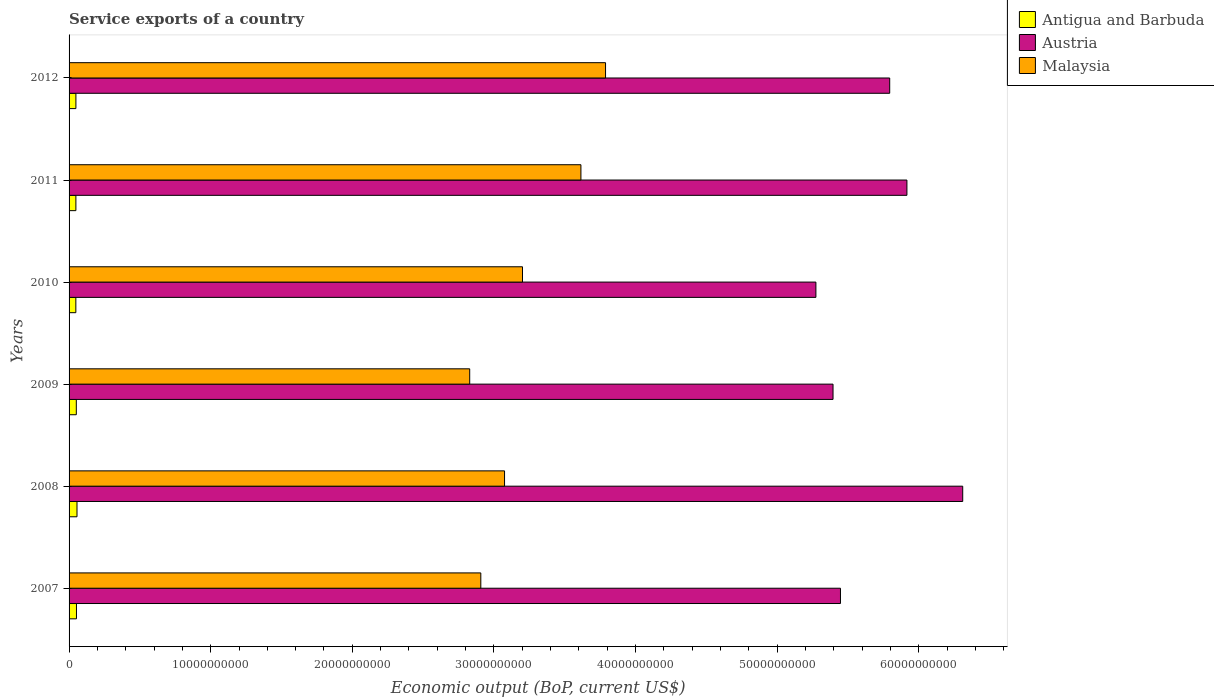How many different coloured bars are there?
Offer a very short reply. 3. How many groups of bars are there?
Provide a short and direct response. 6. Are the number of bars per tick equal to the number of legend labels?
Provide a succinct answer. Yes. How many bars are there on the 3rd tick from the top?
Your answer should be very brief. 3. How many bars are there on the 1st tick from the bottom?
Your answer should be compact. 3. In how many cases, is the number of bars for a given year not equal to the number of legend labels?
Ensure brevity in your answer.  0. What is the service exports in Antigua and Barbuda in 2012?
Keep it short and to the point. 4.83e+08. Across all years, what is the maximum service exports in Antigua and Barbuda?
Give a very brief answer. 5.60e+08. Across all years, what is the minimum service exports in Malaysia?
Your answer should be compact. 2.83e+1. In which year was the service exports in Malaysia minimum?
Give a very brief answer. 2009. What is the total service exports in Antigua and Barbuda in the graph?
Your response must be concise. 3.04e+09. What is the difference between the service exports in Antigua and Barbuda in 2009 and that in 2011?
Your answer should be compact. 2.93e+07. What is the difference between the service exports in Malaysia in 2010 and the service exports in Antigua and Barbuda in 2011?
Offer a very short reply. 3.15e+1. What is the average service exports in Austria per year?
Keep it short and to the point. 5.69e+1. In the year 2010, what is the difference between the service exports in Antigua and Barbuda and service exports in Malaysia?
Offer a very short reply. -3.15e+1. In how many years, is the service exports in Austria greater than 8000000000 US$?
Offer a terse response. 6. What is the ratio of the service exports in Antigua and Barbuda in 2007 to that in 2008?
Provide a short and direct response. 0.93. Is the service exports in Austria in 2010 less than that in 2011?
Keep it short and to the point. Yes. Is the difference between the service exports in Antigua and Barbuda in 2009 and 2012 greater than the difference between the service exports in Malaysia in 2009 and 2012?
Give a very brief answer. Yes. What is the difference between the highest and the second highest service exports in Austria?
Provide a succinct answer. 3.94e+09. What is the difference between the highest and the lowest service exports in Austria?
Ensure brevity in your answer.  1.04e+1. In how many years, is the service exports in Antigua and Barbuda greater than the average service exports in Antigua and Barbuda taken over all years?
Your answer should be compact. 3. Is the sum of the service exports in Malaysia in 2007 and 2009 greater than the maximum service exports in Austria across all years?
Offer a terse response. No. What does the 1st bar from the top in 2007 represents?
Your answer should be very brief. Malaysia. What does the 3rd bar from the bottom in 2009 represents?
Provide a succinct answer. Malaysia. What is the difference between two consecutive major ticks on the X-axis?
Your response must be concise. 1.00e+1. Are the values on the major ticks of X-axis written in scientific E-notation?
Your answer should be very brief. No. Does the graph contain any zero values?
Provide a succinct answer. No. How many legend labels are there?
Provide a short and direct response. 3. What is the title of the graph?
Your answer should be very brief. Service exports of a country. What is the label or title of the X-axis?
Make the answer very short. Economic output (BoP, current US$). What is the Economic output (BoP, current US$) in Antigua and Barbuda in 2007?
Give a very brief answer. 5.22e+08. What is the Economic output (BoP, current US$) in Austria in 2007?
Your response must be concise. 5.45e+1. What is the Economic output (BoP, current US$) of Malaysia in 2007?
Your response must be concise. 2.91e+1. What is the Economic output (BoP, current US$) of Antigua and Barbuda in 2008?
Make the answer very short. 5.60e+08. What is the Economic output (BoP, current US$) in Austria in 2008?
Your answer should be compact. 6.31e+1. What is the Economic output (BoP, current US$) in Malaysia in 2008?
Give a very brief answer. 3.08e+1. What is the Economic output (BoP, current US$) in Antigua and Barbuda in 2009?
Ensure brevity in your answer.  5.11e+08. What is the Economic output (BoP, current US$) of Austria in 2009?
Offer a terse response. 5.39e+1. What is the Economic output (BoP, current US$) in Malaysia in 2009?
Offer a very short reply. 2.83e+1. What is the Economic output (BoP, current US$) of Antigua and Barbuda in 2010?
Your response must be concise. 4.78e+08. What is the Economic output (BoP, current US$) in Austria in 2010?
Offer a very short reply. 5.27e+1. What is the Economic output (BoP, current US$) of Malaysia in 2010?
Ensure brevity in your answer.  3.20e+1. What is the Economic output (BoP, current US$) in Antigua and Barbuda in 2011?
Provide a succinct answer. 4.82e+08. What is the Economic output (BoP, current US$) in Austria in 2011?
Your answer should be very brief. 5.92e+1. What is the Economic output (BoP, current US$) of Malaysia in 2011?
Give a very brief answer. 3.61e+1. What is the Economic output (BoP, current US$) of Antigua and Barbuda in 2012?
Provide a short and direct response. 4.83e+08. What is the Economic output (BoP, current US$) of Austria in 2012?
Give a very brief answer. 5.79e+1. What is the Economic output (BoP, current US$) of Malaysia in 2012?
Make the answer very short. 3.79e+1. Across all years, what is the maximum Economic output (BoP, current US$) in Antigua and Barbuda?
Your answer should be very brief. 5.60e+08. Across all years, what is the maximum Economic output (BoP, current US$) in Austria?
Your answer should be very brief. 6.31e+1. Across all years, what is the maximum Economic output (BoP, current US$) of Malaysia?
Provide a short and direct response. 3.79e+1. Across all years, what is the minimum Economic output (BoP, current US$) in Antigua and Barbuda?
Your response must be concise. 4.78e+08. Across all years, what is the minimum Economic output (BoP, current US$) of Austria?
Your answer should be very brief. 5.27e+1. Across all years, what is the minimum Economic output (BoP, current US$) of Malaysia?
Keep it short and to the point. 2.83e+1. What is the total Economic output (BoP, current US$) of Antigua and Barbuda in the graph?
Your answer should be compact. 3.04e+09. What is the total Economic output (BoP, current US$) of Austria in the graph?
Keep it short and to the point. 3.41e+11. What is the total Economic output (BoP, current US$) of Malaysia in the graph?
Your answer should be very brief. 1.94e+11. What is the difference between the Economic output (BoP, current US$) of Antigua and Barbuda in 2007 and that in 2008?
Ensure brevity in your answer.  -3.80e+07. What is the difference between the Economic output (BoP, current US$) of Austria in 2007 and that in 2008?
Make the answer very short. -8.63e+09. What is the difference between the Economic output (BoP, current US$) of Malaysia in 2007 and that in 2008?
Your answer should be very brief. -1.68e+09. What is the difference between the Economic output (BoP, current US$) of Antigua and Barbuda in 2007 and that in 2009?
Make the answer very short. 1.11e+07. What is the difference between the Economic output (BoP, current US$) of Austria in 2007 and that in 2009?
Provide a short and direct response. 5.24e+08. What is the difference between the Economic output (BoP, current US$) in Malaysia in 2007 and that in 2009?
Provide a succinct answer. 7.84e+08. What is the difference between the Economic output (BoP, current US$) in Antigua and Barbuda in 2007 and that in 2010?
Provide a succinct answer. 4.39e+07. What is the difference between the Economic output (BoP, current US$) of Austria in 2007 and that in 2010?
Provide a succinct answer. 1.73e+09. What is the difference between the Economic output (BoP, current US$) of Malaysia in 2007 and that in 2010?
Provide a short and direct response. -2.94e+09. What is the difference between the Economic output (BoP, current US$) of Antigua and Barbuda in 2007 and that in 2011?
Your answer should be very brief. 4.04e+07. What is the difference between the Economic output (BoP, current US$) of Austria in 2007 and that in 2011?
Ensure brevity in your answer.  -4.69e+09. What is the difference between the Economic output (BoP, current US$) in Malaysia in 2007 and that in 2011?
Offer a terse response. -7.07e+09. What is the difference between the Economic output (BoP, current US$) of Antigua and Barbuda in 2007 and that in 2012?
Give a very brief answer. 3.95e+07. What is the difference between the Economic output (BoP, current US$) in Austria in 2007 and that in 2012?
Ensure brevity in your answer.  -3.48e+09. What is the difference between the Economic output (BoP, current US$) in Malaysia in 2007 and that in 2012?
Make the answer very short. -8.81e+09. What is the difference between the Economic output (BoP, current US$) in Antigua and Barbuda in 2008 and that in 2009?
Offer a terse response. 4.91e+07. What is the difference between the Economic output (BoP, current US$) of Austria in 2008 and that in 2009?
Offer a terse response. 9.16e+09. What is the difference between the Economic output (BoP, current US$) in Malaysia in 2008 and that in 2009?
Offer a very short reply. 2.46e+09. What is the difference between the Economic output (BoP, current US$) in Antigua and Barbuda in 2008 and that in 2010?
Your answer should be very brief. 8.19e+07. What is the difference between the Economic output (BoP, current US$) in Austria in 2008 and that in 2010?
Provide a short and direct response. 1.04e+1. What is the difference between the Economic output (BoP, current US$) in Malaysia in 2008 and that in 2010?
Your answer should be very brief. -1.27e+09. What is the difference between the Economic output (BoP, current US$) of Antigua and Barbuda in 2008 and that in 2011?
Your response must be concise. 7.84e+07. What is the difference between the Economic output (BoP, current US$) in Austria in 2008 and that in 2011?
Your answer should be very brief. 3.94e+09. What is the difference between the Economic output (BoP, current US$) of Malaysia in 2008 and that in 2011?
Provide a short and direct response. -5.39e+09. What is the difference between the Economic output (BoP, current US$) in Antigua and Barbuda in 2008 and that in 2012?
Provide a succinct answer. 7.75e+07. What is the difference between the Economic output (BoP, current US$) in Austria in 2008 and that in 2012?
Your answer should be compact. 5.16e+09. What is the difference between the Economic output (BoP, current US$) in Malaysia in 2008 and that in 2012?
Your answer should be compact. -7.13e+09. What is the difference between the Economic output (BoP, current US$) of Antigua and Barbuda in 2009 and that in 2010?
Keep it short and to the point. 3.28e+07. What is the difference between the Economic output (BoP, current US$) in Austria in 2009 and that in 2010?
Make the answer very short. 1.21e+09. What is the difference between the Economic output (BoP, current US$) of Malaysia in 2009 and that in 2010?
Offer a very short reply. -3.73e+09. What is the difference between the Economic output (BoP, current US$) in Antigua and Barbuda in 2009 and that in 2011?
Keep it short and to the point. 2.93e+07. What is the difference between the Economic output (BoP, current US$) in Austria in 2009 and that in 2011?
Provide a succinct answer. -5.22e+09. What is the difference between the Economic output (BoP, current US$) in Malaysia in 2009 and that in 2011?
Give a very brief answer. -7.85e+09. What is the difference between the Economic output (BoP, current US$) in Antigua and Barbuda in 2009 and that in 2012?
Give a very brief answer. 2.84e+07. What is the difference between the Economic output (BoP, current US$) of Austria in 2009 and that in 2012?
Ensure brevity in your answer.  -4.00e+09. What is the difference between the Economic output (BoP, current US$) in Malaysia in 2009 and that in 2012?
Provide a short and direct response. -9.59e+09. What is the difference between the Economic output (BoP, current US$) in Antigua and Barbuda in 2010 and that in 2011?
Make the answer very short. -3.49e+06. What is the difference between the Economic output (BoP, current US$) of Austria in 2010 and that in 2011?
Your response must be concise. -6.43e+09. What is the difference between the Economic output (BoP, current US$) of Malaysia in 2010 and that in 2011?
Your response must be concise. -4.13e+09. What is the difference between the Economic output (BoP, current US$) in Antigua and Barbuda in 2010 and that in 2012?
Your answer should be very brief. -4.39e+06. What is the difference between the Economic output (BoP, current US$) in Austria in 2010 and that in 2012?
Make the answer very short. -5.21e+09. What is the difference between the Economic output (BoP, current US$) of Malaysia in 2010 and that in 2012?
Offer a very short reply. -5.86e+09. What is the difference between the Economic output (BoP, current US$) in Antigua and Barbuda in 2011 and that in 2012?
Offer a terse response. -9.03e+05. What is the difference between the Economic output (BoP, current US$) of Austria in 2011 and that in 2012?
Your answer should be very brief. 1.22e+09. What is the difference between the Economic output (BoP, current US$) in Malaysia in 2011 and that in 2012?
Keep it short and to the point. -1.74e+09. What is the difference between the Economic output (BoP, current US$) in Antigua and Barbuda in 2007 and the Economic output (BoP, current US$) in Austria in 2008?
Your answer should be very brief. -6.26e+1. What is the difference between the Economic output (BoP, current US$) in Antigua and Barbuda in 2007 and the Economic output (BoP, current US$) in Malaysia in 2008?
Your answer should be very brief. -3.02e+1. What is the difference between the Economic output (BoP, current US$) in Austria in 2007 and the Economic output (BoP, current US$) in Malaysia in 2008?
Provide a short and direct response. 2.37e+1. What is the difference between the Economic output (BoP, current US$) in Antigua and Barbuda in 2007 and the Economic output (BoP, current US$) in Austria in 2009?
Your answer should be very brief. -5.34e+1. What is the difference between the Economic output (BoP, current US$) in Antigua and Barbuda in 2007 and the Economic output (BoP, current US$) in Malaysia in 2009?
Offer a very short reply. -2.78e+1. What is the difference between the Economic output (BoP, current US$) in Austria in 2007 and the Economic output (BoP, current US$) in Malaysia in 2009?
Offer a terse response. 2.62e+1. What is the difference between the Economic output (BoP, current US$) in Antigua and Barbuda in 2007 and the Economic output (BoP, current US$) in Austria in 2010?
Offer a very short reply. -5.22e+1. What is the difference between the Economic output (BoP, current US$) in Antigua and Barbuda in 2007 and the Economic output (BoP, current US$) in Malaysia in 2010?
Provide a short and direct response. -3.15e+1. What is the difference between the Economic output (BoP, current US$) in Austria in 2007 and the Economic output (BoP, current US$) in Malaysia in 2010?
Your answer should be very brief. 2.25e+1. What is the difference between the Economic output (BoP, current US$) in Antigua and Barbuda in 2007 and the Economic output (BoP, current US$) in Austria in 2011?
Provide a short and direct response. -5.86e+1. What is the difference between the Economic output (BoP, current US$) of Antigua and Barbuda in 2007 and the Economic output (BoP, current US$) of Malaysia in 2011?
Give a very brief answer. -3.56e+1. What is the difference between the Economic output (BoP, current US$) in Austria in 2007 and the Economic output (BoP, current US$) in Malaysia in 2011?
Provide a succinct answer. 1.83e+1. What is the difference between the Economic output (BoP, current US$) of Antigua and Barbuda in 2007 and the Economic output (BoP, current US$) of Austria in 2012?
Make the answer very short. -5.74e+1. What is the difference between the Economic output (BoP, current US$) of Antigua and Barbuda in 2007 and the Economic output (BoP, current US$) of Malaysia in 2012?
Your response must be concise. -3.74e+1. What is the difference between the Economic output (BoP, current US$) of Austria in 2007 and the Economic output (BoP, current US$) of Malaysia in 2012?
Your answer should be compact. 1.66e+1. What is the difference between the Economic output (BoP, current US$) in Antigua and Barbuda in 2008 and the Economic output (BoP, current US$) in Austria in 2009?
Your response must be concise. -5.34e+1. What is the difference between the Economic output (BoP, current US$) in Antigua and Barbuda in 2008 and the Economic output (BoP, current US$) in Malaysia in 2009?
Keep it short and to the point. -2.77e+1. What is the difference between the Economic output (BoP, current US$) in Austria in 2008 and the Economic output (BoP, current US$) in Malaysia in 2009?
Your response must be concise. 3.48e+1. What is the difference between the Economic output (BoP, current US$) of Antigua and Barbuda in 2008 and the Economic output (BoP, current US$) of Austria in 2010?
Provide a short and direct response. -5.22e+1. What is the difference between the Economic output (BoP, current US$) in Antigua and Barbuda in 2008 and the Economic output (BoP, current US$) in Malaysia in 2010?
Keep it short and to the point. -3.15e+1. What is the difference between the Economic output (BoP, current US$) of Austria in 2008 and the Economic output (BoP, current US$) of Malaysia in 2010?
Your response must be concise. 3.11e+1. What is the difference between the Economic output (BoP, current US$) of Antigua and Barbuda in 2008 and the Economic output (BoP, current US$) of Austria in 2011?
Give a very brief answer. -5.86e+1. What is the difference between the Economic output (BoP, current US$) in Antigua and Barbuda in 2008 and the Economic output (BoP, current US$) in Malaysia in 2011?
Ensure brevity in your answer.  -3.56e+1. What is the difference between the Economic output (BoP, current US$) of Austria in 2008 and the Economic output (BoP, current US$) of Malaysia in 2011?
Your response must be concise. 2.70e+1. What is the difference between the Economic output (BoP, current US$) of Antigua and Barbuda in 2008 and the Economic output (BoP, current US$) of Austria in 2012?
Make the answer very short. -5.74e+1. What is the difference between the Economic output (BoP, current US$) in Antigua and Barbuda in 2008 and the Economic output (BoP, current US$) in Malaysia in 2012?
Give a very brief answer. -3.73e+1. What is the difference between the Economic output (BoP, current US$) in Austria in 2008 and the Economic output (BoP, current US$) in Malaysia in 2012?
Keep it short and to the point. 2.52e+1. What is the difference between the Economic output (BoP, current US$) in Antigua and Barbuda in 2009 and the Economic output (BoP, current US$) in Austria in 2010?
Your answer should be very brief. -5.22e+1. What is the difference between the Economic output (BoP, current US$) in Antigua and Barbuda in 2009 and the Economic output (BoP, current US$) in Malaysia in 2010?
Keep it short and to the point. -3.15e+1. What is the difference between the Economic output (BoP, current US$) in Austria in 2009 and the Economic output (BoP, current US$) in Malaysia in 2010?
Make the answer very short. 2.19e+1. What is the difference between the Economic output (BoP, current US$) in Antigua and Barbuda in 2009 and the Economic output (BoP, current US$) in Austria in 2011?
Offer a terse response. -5.87e+1. What is the difference between the Economic output (BoP, current US$) of Antigua and Barbuda in 2009 and the Economic output (BoP, current US$) of Malaysia in 2011?
Offer a terse response. -3.56e+1. What is the difference between the Economic output (BoP, current US$) in Austria in 2009 and the Economic output (BoP, current US$) in Malaysia in 2011?
Your answer should be compact. 1.78e+1. What is the difference between the Economic output (BoP, current US$) of Antigua and Barbuda in 2009 and the Economic output (BoP, current US$) of Austria in 2012?
Give a very brief answer. -5.74e+1. What is the difference between the Economic output (BoP, current US$) of Antigua and Barbuda in 2009 and the Economic output (BoP, current US$) of Malaysia in 2012?
Give a very brief answer. -3.74e+1. What is the difference between the Economic output (BoP, current US$) of Austria in 2009 and the Economic output (BoP, current US$) of Malaysia in 2012?
Make the answer very short. 1.61e+1. What is the difference between the Economic output (BoP, current US$) in Antigua and Barbuda in 2010 and the Economic output (BoP, current US$) in Austria in 2011?
Offer a terse response. -5.87e+1. What is the difference between the Economic output (BoP, current US$) of Antigua and Barbuda in 2010 and the Economic output (BoP, current US$) of Malaysia in 2011?
Your response must be concise. -3.57e+1. What is the difference between the Economic output (BoP, current US$) in Austria in 2010 and the Economic output (BoP, current US$) in Malaysia in 2011?
Provide a succinct answer. 1.66e+1. What is the difference between the Economic output (BoP, current US$) of Antigua and Barbuda in 2010 and the Economic output (BoP, current US$) of Austria in 2012?
Your answer should be compact. -5.75e+1. What is the difference between the Economic output (BoP, current US$) in Antigua and Barbuda in 2010 and the Economic output (BoP, current US$) in Malaysia in 2012?
Your answer should be compact. -3.74e+1. What is the difference between the Economic output (BoP, current US$) in Austria in 2010 and the Economic output (BoP, current US$) in Malaysia in 2012?
Offer a terse response. 1.49e+1. What is the difference between the Economic output (BoP, current US$) of Antigua and Barbuda in 2011 and the Economic output (BoP, current US$) of Austria in 2012?
Make the answer very short. -5.75e+1. What is the difference between the Economic output (BoP, current US$) in Antigua and Barbuda in 2011 and the Economic output (BoP, current US$) in Malaysia in 2012?
Give a very brief answer. -3.74e+1. What is the difference between the Economic output (BoP, current US$) of Austria in 2011 and the Economic output (BoP, current US$) of Malaysia in 2012?
Make the answer very short. 2.13e+1. What is the average Economic output (BoP, current US$) in Antigua and Barbuda per year?
Make the answer very short. 5.06e+08. What is the average Economic output (BoP, current US$) of Austria per year?
Provide a succinct answer. 5.69e+1. What is the average Economic output (BoP, current US$) in Malaysia per year?
Make the answer very short. 3.24e+1. In the year 2007, what is the difference between the Economic output (BoP, current US$) in Antigua and Barbuda and Economic output (BoP, current US$) in Austria?
Provide a succinct answer. -5.40e+1. In the year 2007, what is the difference between the Economic output (BoP, current US$) of Antigua and Barbuda and Economic output (BoP, current US$) of Malaysia?
Give a very brief answer. -2.86e+1. In the year 2007, what is the difference between the Economic output (BoP, current US$) of Austria and Economic output (BoP, current US$) of Malaysia?
Offer a very short reply. 2.54e+1. In the year 2008, what is the difference between the Economic output (BoP, current US$) in Antigua and Barbuda and Economic output (BoP, current US$) in Austria?
Your answer should be compact. -6.25e+1. In the year 2008, what is the difference between the Economic output (BoP, current US$) of Antigua and Barbuda and Economic output (BoP, current US$) of Malaysia?
Provide a short and direct response. -3.02e+1. In the year 2008, what is the difference between the Economic output (BoP, current US$) in Austria and Economic output (BoP, current US$) in Malaysia?
Your answer should be compact. 3.24e+1. In the year 2009, what is the difference between the Economic output (BoP, current US$) in Antigua and Barbuda and Economic output (BoP, current US$) in Austria?
Your answer should be compact. -5.34e+1. In the year 2009, what is the difference between the Economic output (BoP, current US$) in Antigua and Barbuda and Economic output (BoP, current US$) in Malaysia?
Your answer should be very brief. -2.78e+1. In the year 2009, what is the difference between the Economic output (BoP, current US$) in Austria and Economic output (BoP, current US$) in Malaysia?
Keep it short and to the point. 2.57e+1. In the year 2010, what is the difference between the Economic output (BoP, current US$) in Antigua and Barbuda and Economic output (BoP, current US$) in Austria?
Offer a terse response. -5.23e+1. In the year 2010, what is the difference between the Economic output (BoP, current US$) in Antigua and Barbuda and Economic output (BoP, current US$) in Malaysia?
Make the answer very short. -3.15e+1. In the year 2010, what is the difference between the Economic output (BoP, current US$) of Austria and Economic output (BoP, current US$) of Malaysia?
Keep it short and to the point. 2.07e+1. In the year 2011, what is the difference between the Economic output (BoP, current US$) of Antigua and Barbuda and Economic output (BoP, current US$) of Austria?
Offer a terse response. -5.87e+1. In the year 2011, what is the difference between the Economic output (BoP, current US$) in Antigua and Barbuda and Economic output (BoP, current US$) in Malaysia?
Provide a succinct answer. -3.57e+1. In the year 2011, what is the difference between the Economic output (BoP, current US$) of Austria and Economic output (BoP, current US$) of Malaysia?
Provide a short and direct response. 2.30e+1. In the year 2012, what is the difference between the Economic output (BoP, current US$) in Antigua and Barbuda and Economic output (BoP, current US$) in Austria?
Your response must be concise. -5.75e+1. In the year 2012, what is the difference between the Economic output (BoP, current US$) in Antigua and Barbuda and Economic output (BoP, current US$) in Malaysia?
Keep it short and to the point. -3.74e+1. In the year 2012, what is the difference between the Economic output (BoP, current US$) in Austria and Economic output (BoP, current US$) in Malaysia?
Make the answer very short. 2.01e+1. What is the ratio of the Economic output (BoP, current US$) of Antigua and Barbuda in 2007 to that in 2008?
Your answer should be very brief. 0.93. What is the ratio of the Economic output (BoP, current US$) in Austria in 2007 to that in 2008?
Your response must be concise. 0.86. What is the ratio of the Economic output (BoP, current US$) in Malaysia in 2007 to that in 2008?
Offer a terse response. 0.95. What is the ratio of the Economic output (BoP, current US$) of Antigua and Barbuda in 2007 to that in 2009?
Provide a short and direct response. 1.02. What is the ratio of the Economic output (BoP, current US$) in Austria in 2007 to that in 2009?
Give a very brief answer. 1.01. What is the ratio of the Economic output (BoP, current US$) of Malaysia in 2007 to that in 2009?
Make the answer very short. 1.03. What is the ratio of the Economic output (BoP, current US$) of Antigua and Barbuda in 2007 to that in 2010?
Provide a short and direct response. 1.09. What is the ratio of the Economic output (BoP, current US$) of Austria in 2007 to that in 2010?
Ensure brevity in your answer.  1.03. What is the ratio of the Economic output (BoP, current US$) of Malaysia in 2007 to that in 2010?
Provide a succinct answer. 0.91. What is the ratio of the Economic output (BoP, current US$) in Antigua and Barbuda in 2007 to that in 2011?
Provide a succinct answer. 1.08. What is the ratio of the Economic output (BoP, current US$) in Austria in 2007 to that in 2011?
Your response must be concise. 0.92. What is the ratio of the Economic output (BoP, current US$) of Malaysia in 2007 to that in 2011?
Make the answer very short. 0.8. What is the ratio of the Economic output (BoP, current US$) in Antigua and Barbuda in 2007 to that in 2012?
Keep it short and to the point. 1.08. What is the ratio of the Economic output (BoP, current US$) in Malaysia in 2007 to that in 2012?
Your answer should be compact. 0.77. What is the ratio of the Economic output (BoP, current US$) in Antigua and Barbuda in 2008 to that in 2009?
Your response must be concise. 1.1. What is the ratio of the Economic output (BoP, current US$) of Austria in 2008 to that in 2009?
Give a very brief answer. 1.17. What is the ratio of the Economic output (BoP, current US$) of Malaysia in 2008 to that in 2009?
Provide a short and direct response. 1.09. What is the ratio of the Economic output (BoP, current US$) of Antigua and Barbuda in 2008 to that in 2010?
Your answer should be compact. 1.17. What is the ratio of the Economic output (BoP, current US$) of Austria in 2008 to that in 2010?
Give a very brief answer. 1.2. What is the ratio of the Economic output (BoP, current US$) of Malaysia in 2008 to that in 2010?
Offer a very short reply. 0.96. What is the ratio of the Economic output (BoP, current US$) in Antigua and Barbuda in 2008 to that in 2011?
Your response must be concise. 1.16. What is the ratio of the Economic output (BoP, current US$) of Austria in 2008 to that in 2011?
Ensure brevity in your answer.  1.07. What is the ratio of the Economic output (BoP, current US$) of Malaysia in 2008 to that in 2011?
Ensure brevity in your answer.  0.85. What is the ratio of the Economic output (BoP, current US$) of Antigua and Barbuda in 2008 to that in 2012?
Keep it short and to the point. 1.16. What is the ratio of the Economic output (BoP, current US$) in Austria in 2008 to that in 2012?
Offer a terse response. 1.09. What is the ratio of the Economic output (BoP, current US$) of Malaysia in 2008 to that in 2012?
Make the answer very short. 0.81. What is the ratio of the Economic output (BoP, current US$) in Antigua and Barbuda in 2009 to that in 2010?
Your response must be concise. 1.07. What is the ratio of the Economic output (BoP, current US$) in Austria in 2009 to that in 2010?
Ensure brevity in your answer.  1.02. What is the ratio of the Economic output (BoP, current US$) of Malaysia in 2009 to that in 2010?
Offer a very short reply. 0.88. What is the ratio of the Economic output (BoP, current US$) of Antigua and Barbuda in 2009 to that in 2011?
Offer a very short reply. 1.06. What is the ratio of the Economic output (BoP, current US$) of Austria in 2009 to that in 2011?
Your response must be concise. 0.91. What is the ratio of the Economic output (BoP, current US$) in Malaysia in 2009 to that in 2011?
Your answer should be very brief. 0.78. What is the ratio of the Economic output (BoP, current US$) in Antigua and Barbuda in 2009 to that in 2012?
Provide a succinct answer. 1.06. What is the ratio of the Economic output (BoP, current US$) of Austria in 2009 to that in 2012?
Offer a very short reply. 0.93. What is the ratio of the Economic output (BoP, current US$) in Malaysia in 2009 to that in 2012?
Make the answer very short. 0.75. What is the ratio of the Economic output (BoP, current US$) in Austria in 2010 to that in 2011?
Offer a very short reply. 0.89. What is the ratio of the Economic output (BoP, current US$) in Malaysia in 2010 to that in 2011?
Ensure brevity in your answer.  0.89. What is the ratio of the Economic output (BoP, current US$) of Antigua and Barbuda in 2010 to that in 2012?
Ensure brevity in your answer.  0.99. What is the ratio of the Economic output (BoP, current US$) of Austria in 2010 to that in 2012?
Offer a terse response. 0.91. What is the ratio of the Economic output (BoP, current US$) of Malaysia in 2010 to that in 2012?
Keep it short and to the point. 0.85. What is the ratio of the Economic output (BoP, current US$) of Antigua and Barbuda in 2011 to that in 2012?
Offer a terse response. 1. What is the ratio of the Economic output (BoP, current US$) of Malaysia in 2011 to that in 2012?
Offer a very short reply. 0.95. What is the difference between the highest and the second highest Economic output (BoP, current US$) in Antigua and Barbuda?
Make the answer very short. 3.80e+07. What is the difference between the highest and the second highest Economic output (BoP, current US$) in Austria?
Offer a terse response. 3.94e+09. What is the difference between the highest and the second highest Economic output (BoP, current US$) in Malaysia?
Your answer should be compact. 1.74e+09. What is the difference between the highest and the lowest Economic output (BoP, current US$) of Antigua and Barbuda?
Ensure brevity in your answer.  8.19e+07. What is the difference between the highest and the lowest Economic output (BoP, current US$) of Austria?
Keep it short and to the point. 1.04e+1. What is the difference between the highest and the lowest Economic output (BoP, current US$) of Malaysia?
Keep it short and to the point. 9.59e+09. 